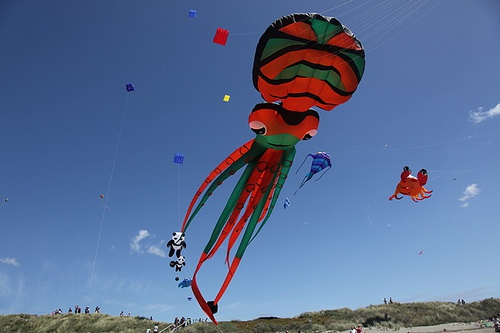Describe the objects in this image and their specific colors. I can see kite in navy, black, brown, gray, and maroon tones, people in navy, gray, lightblue, darkgray, and black tones, kite in navy, brown, maroon, black, and gray tones, kite in navy, gray, blue, and darkblue tones, and kite in navy, darkgray, and gray tones in this image. 